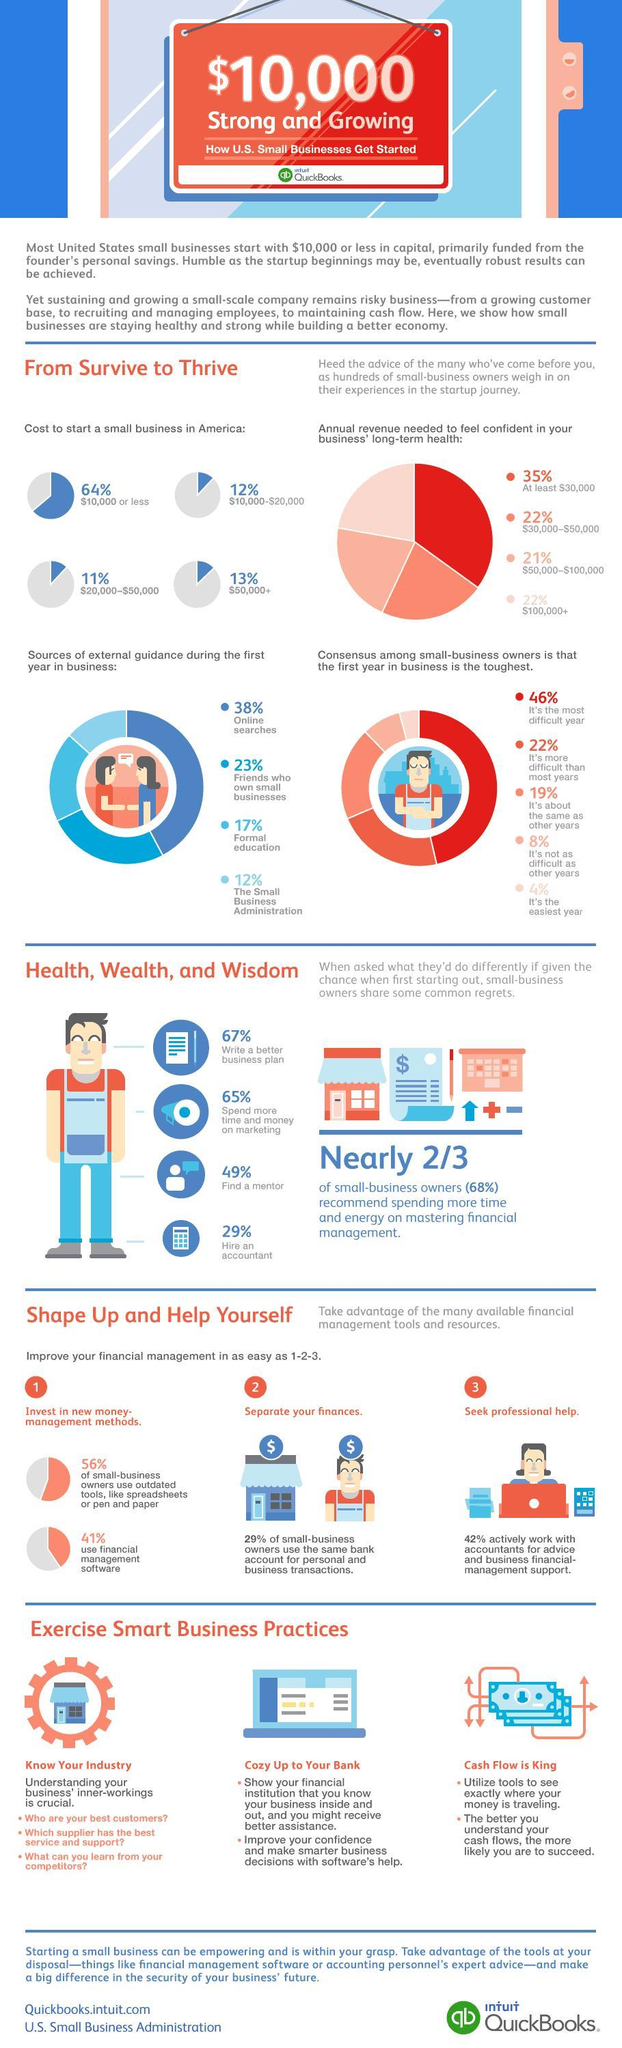what percentage of business needs between $ 10,000 - $ 20,000to start
Answer the question with a short phrase. 12% how much do friends who have own small business act as sources of external guidance 23% what is the second step in improving your financial management separate your finance how many believe that first year is not as difficult as other years 8% what percentage of business needs between $10,000 - $ 50,000 to start 33 what percentage of business needs more than $ 50,000 to start 13% 